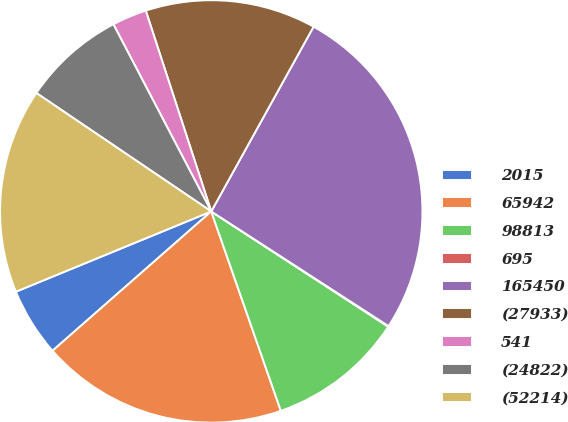Convert chart to OTSL. <chart><loc_0><loc_0><loc_500><loc_500><pie_chart><fcel>2015<fcel>65942<fcel>98813<fcel>695<fcel>165450<fcel>(27933)<fcel>541<fcel>(24822)<fcel>(52214)<nl><fcel>5.26%<fcel>18.88%<fcel>10.47%<fcel>0.05%<fcel>26.09%<fcel>13.07%<fcel>2.65%<fcel>7.86%<fcel>15.68%<nl></chart> 